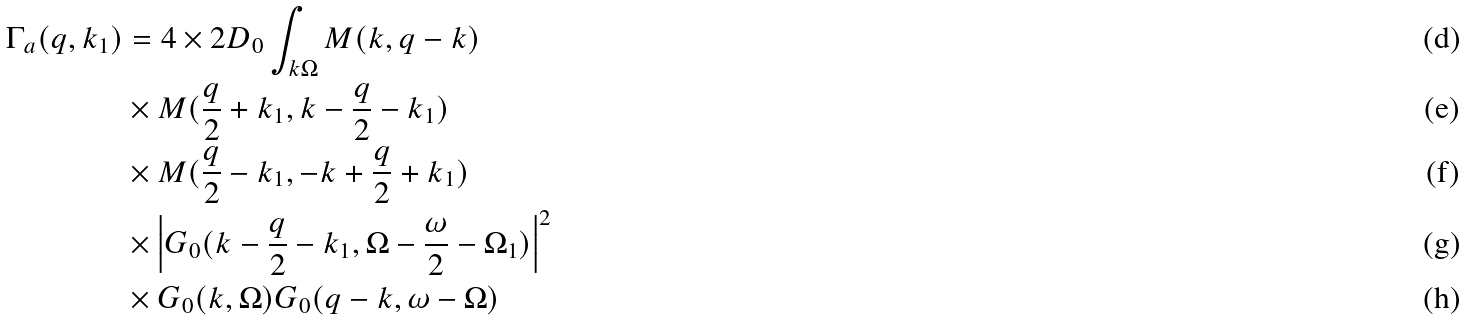Convert formula to latex. <formula><loc_0><loc_0><loc_500><loc_500>\Gamma _ { a } ( { q } , { k _ { 1 } } ) & = 4 \times 2 D _ { 0 } \int _ { k \Omega } M ( { k } , { q } - { k } ) \\ & \times M ( \frac { q } { 2 } + { k } _ { 1 } , { k } - \frac { q } { 2 } - { k } _ { 1 } ) \\ & \times M ( \frac { q } { 2 } - { k _ { 1 } } , - { k } + \frac { q } { 2 } + { k _ { 1 } } ) \\ & \times \left | G _ { 0 } ( { k } - \frac { q } { 2 } - { k } _ { 1 } , \Omega - \frac { \omega } { 2 } - \Omega _ { 1 } ) \right | ^ { 2 } \\ & \times G _ { 0 } ( { k } , \Omega ) G _ { 0 } ( { q } - { k } , \omega - \Omega )</formula> 